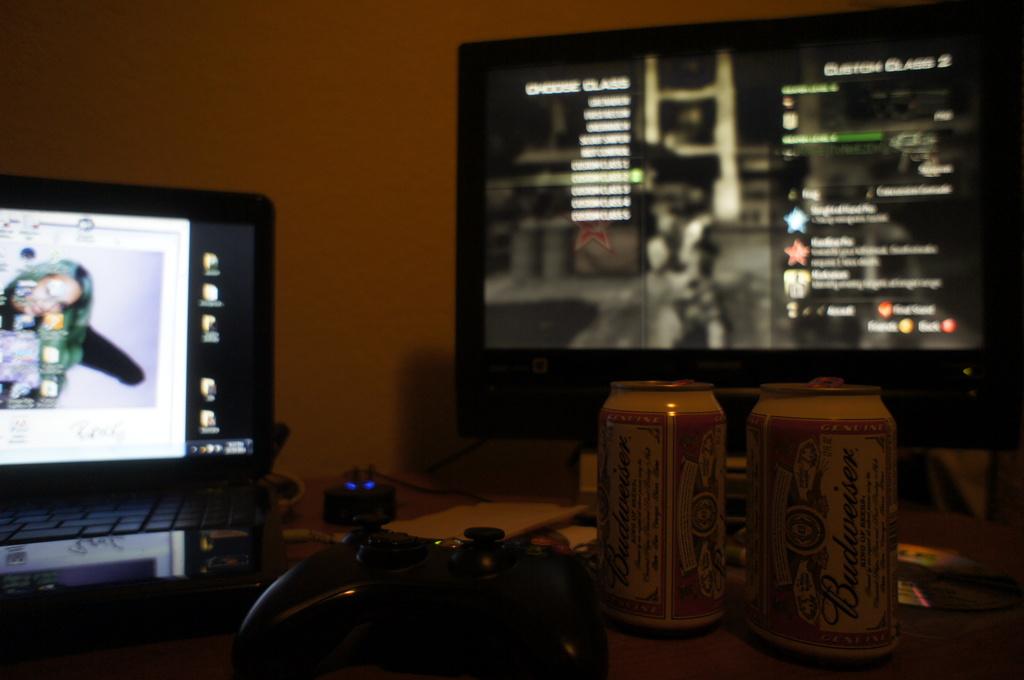What kind of beer is shown?
Offer a very short reply. Budweiser. 